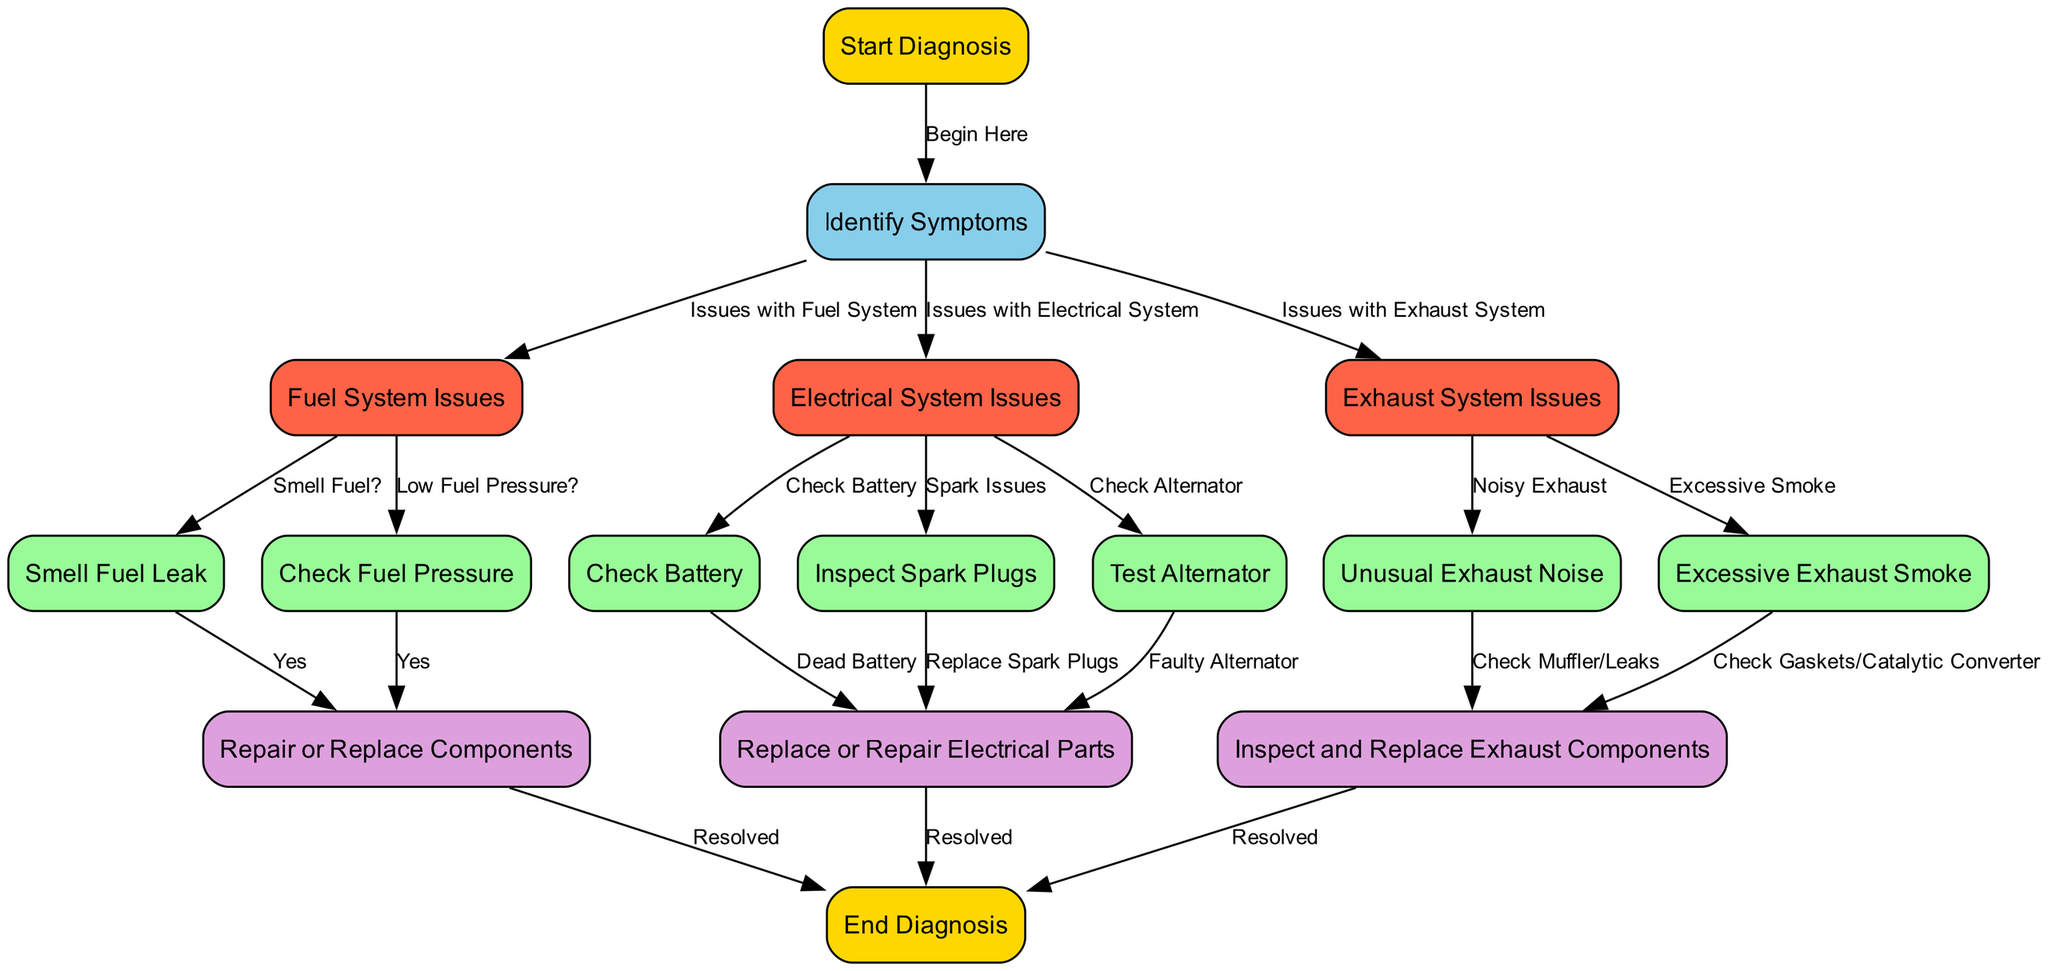What is the first step in the diagnosis? The diagram starts with the node labeled "Start Diagnosis," which indicates where the diagnostic procedure begins.
Answer: Start Diagnosis How many main issue categories are there in the diagram? The diagram branches from "Identify Symptoms" into three main categories: "Fuel System Issues," "Electrical System Issues," and "Exhaust System Issues." Therefore, there are three main issue categories.
Answer: Three What follows after you identify electrical system issues? After identifying "Electrical System Issues," the next node is "Check Battery," indicating the action to take in this branch of the diagnosis.
Answer: Check Battery If you smell a fuel leak, which node do you proceed to? If you identify the symptom of a fuel leak by selecting "Smell Fuel Leak," you proceed to the node "Repair or Replace Components," indicating the action to take regarding the fuel system issue.
Answer: Repair or Replace Components What type of issues does the node "Excessive Exhaust Smoke" represent? The node labeled "Excessive Exhaust Smoke" represents a specific type of issue related to the "Exhaust System Issues." It is a symptom that can occur when there is a problem in the exhaust system.
Answer: Exhaust System Issues Which diagnosis path leads to "Resolved" through electrical systems? After identifying "Electrical System Issues," the path is: "Check Battery," followed by "Dead Battery" leading to "Replace or Repair Electrical Parts," and then finally to "Resolved."
Answer: Replace or Repair Electrical Parts What is the outcome if no issues are resolved in the exhaust system? If there are no issues resolved, specifically if you reach the end of the path from "Unusual Exhaust Noise" or "Excessive Exhaust Smoke" without a corresponding solution node indicating resolution, it suggests the issues remain unaddressed. The diagram does not show paths beyond "Resolved," meaning unresolved issues would need additional steps outside this flowchart.
Answer: Unresolved issues remain How does the diagram visually separate solutions from checks? The diagram uses distinct colors to differentiate node types: solution nodes are colored plum, while check nodes are pale green. This color coding provides a clear visual distinction between actions needed to check systems and those indicating repairs or solutions.
Answer: Color coding What is the connection between "Check Alternator" and "Faulty Alternator"? "Check Alternator" is a necessary step after identifying electrical system issues and leads to the conclusion "Faulty Alternator," indicating that if the alternator is not functioning correctly, it requires addressing. This shows a directional flow where investigation leads to potential diagnosis.
Answer: Directional flow 